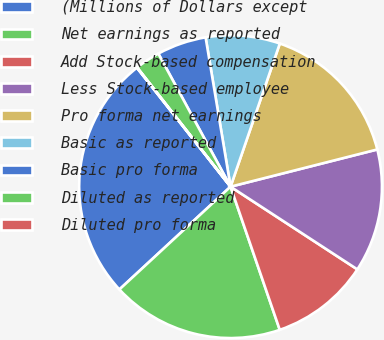Convert chart. <chart><loc_0><loc_0><loc_500><loc_500><pie_chart><fcel>(Millions of Dollars except<fcel>Net earnings as reported<fcel>Add Stock-based compensation<fcel>Less Stock-based employee<fcel>Pro forma net earnings<fcel>Basic as reported<fcel>Basic pro forma<fcel>Diluted as reported<fcel>Diluted pro forma<nl><fcel>26.26%<fcel>18.39%<fcel>10.53%<fcel>13.15%<fcel>15.77%<fcel>7.91%<fcel>5.28%<fcel>2.66%<fcel>0.04%<nl></chart> 